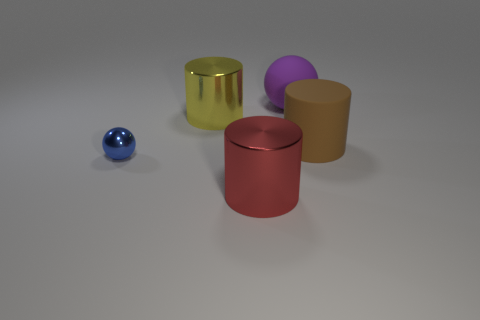Subtract 1 cylinders. How many cylinders are left? 2 Subtract all yellow shiny cylinders. How many cylinders are left? 2 Subtract all balls. How many objects are left? 3 Add 3 large purple spheres. How many large purple spheres are left? 4 Add 5 metallic things. How many metallic things exist? 8 Add 1 small cyan things. How many objects exist? 6 Subtract all yellow cylinders. How many cylinders are left? 2 Subtract 1 brown cylinders. How many objects are left? 4 Subtract all brown cylinders. Subtract all red spheres. How many cylinders are left? 2 Subtract all gray blocks. How many brown cylinders are left? 1 